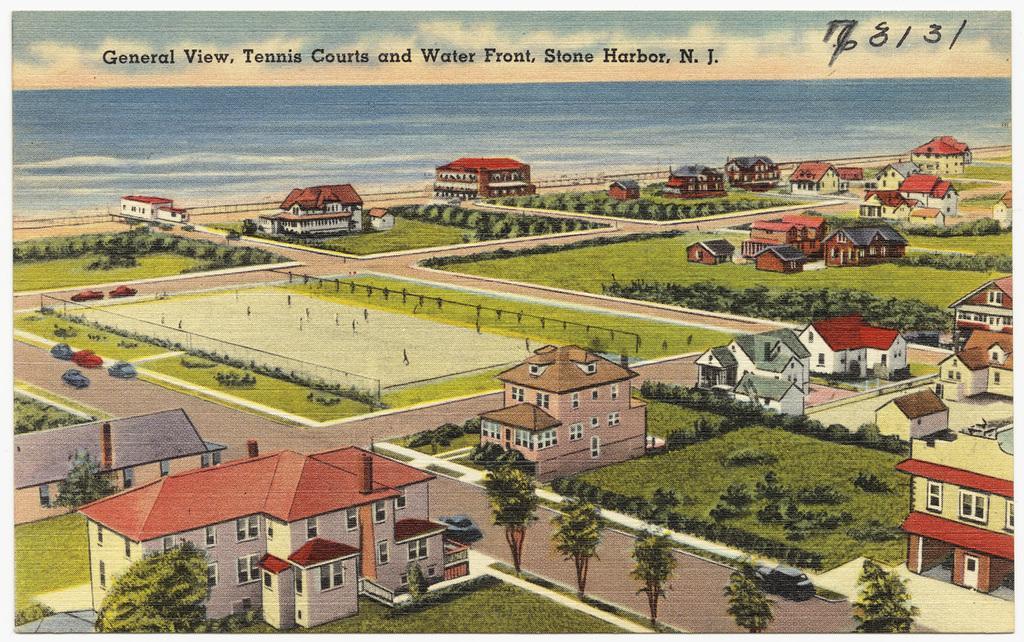How would you summarize this image in a sentence or two? Here we can see houses,trees and grass. Background we can see water and sky with clouds. Top of the image we can see text and number. 